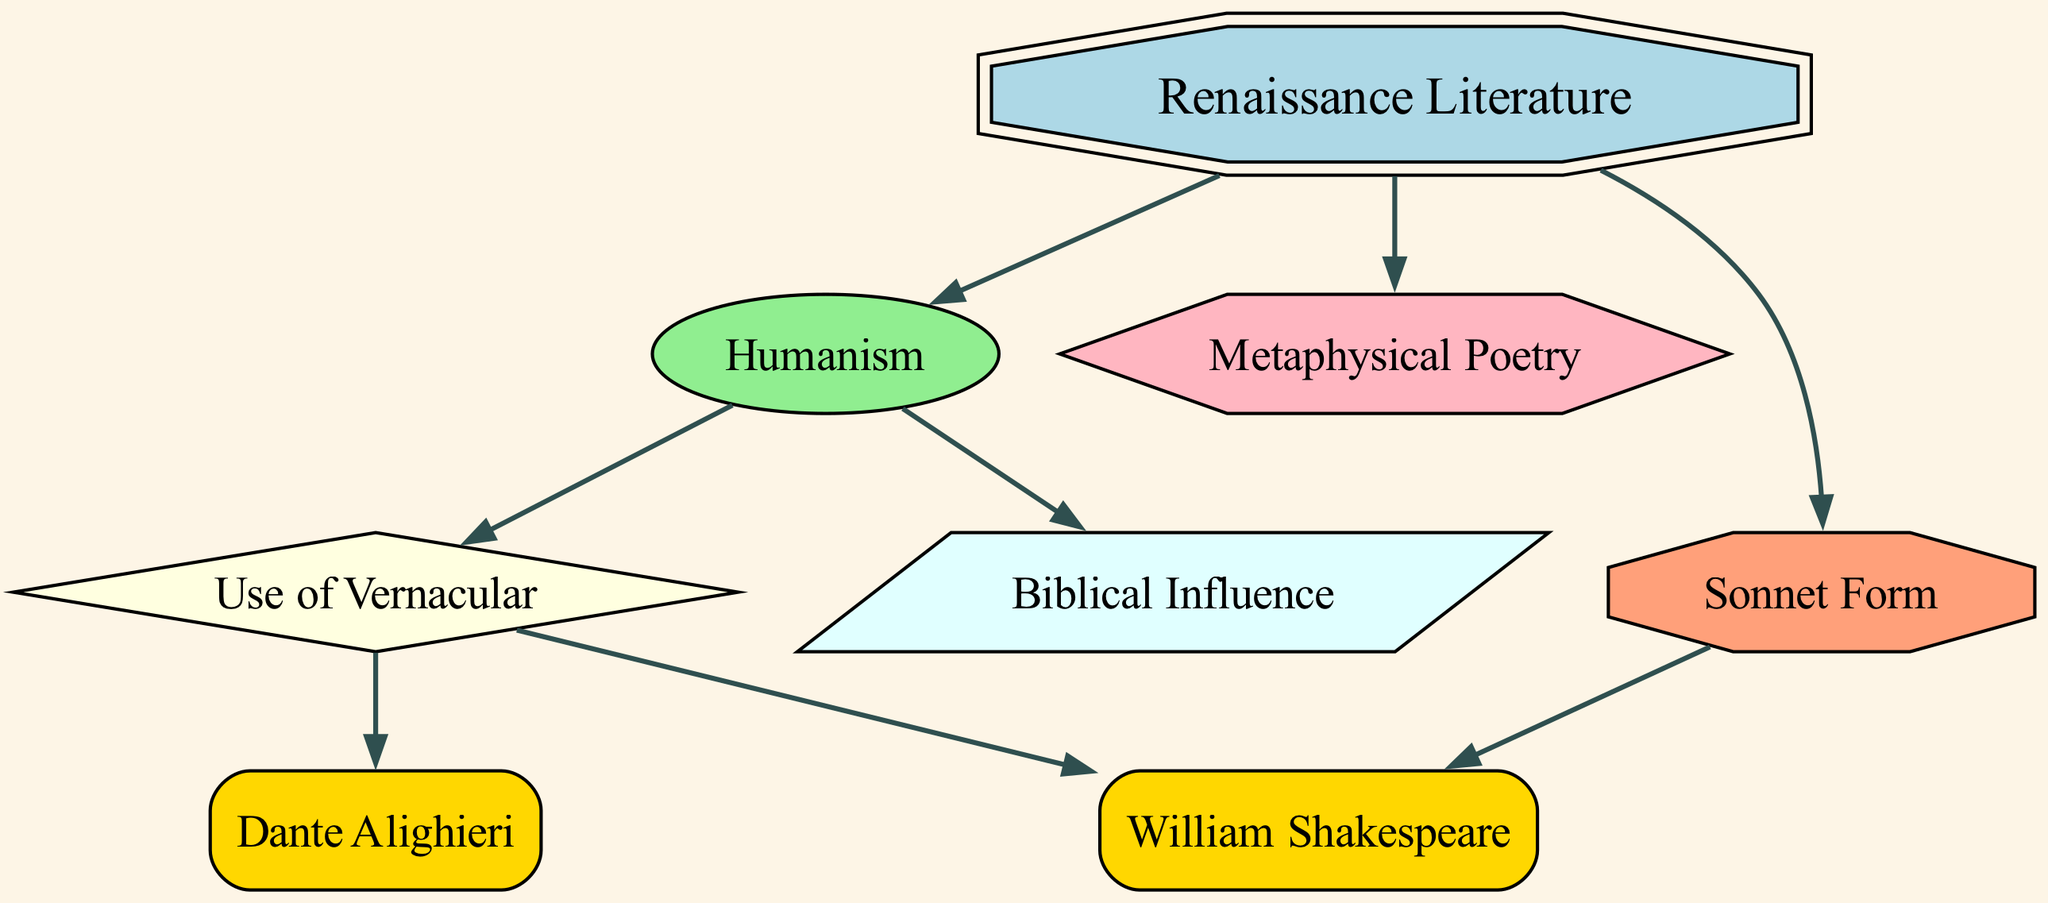What is the main subject of the diagram? The main subject, as indicated by the central or prominent node, is "Renaissance Literature." It serves as the focal point from which other concepts branch out.
Answer: Renaissance Literature How many nodes are there in the diagram? To determine the number of nodes, we count all the distinct entries in the 'nodes' list, which totals to 8.
Answer: 8 Which concept influences the use of vernacular? The diagram shows that "Humanism" directly influences "Use of Vernacular," indicating its pivotal role in promoting vernacular literature.
Answer: Humanism Who is connected through the use of vernacular? Both "William Shakespeare" and "Dante Alighieri" are connected through the "Use of Vernacular," as they derive from this concept.
Answer: William Shakespeare and Dante Alighieri What type of poetry is directly mentioned in the diagram? The diagram includes "Metaphysical Poetry," which is indicated as a separate node, showing its specific role in Renaissance literature.
Answer: Metaphysical Poetry How many connections does "William Shakespeare" have? "William Shakespeare" has two connections in the diagram: one from "Use of Vernacular" and another from "Sonnet Form." Therefore, the total is 2.
Answer: 2 Which concept is considered a direct result of Renaissance Literature? Two concepts, "Metaphysical Poetry" and "Sonnet Form," are both direct results of "Renaissance Literature," indicating its diverse impacts.
Answer: Metaphysical Poetry and Sonnet Form What shape is used for "Humanism"? The diagram specifies that "Humanism" is presented in an ellipse shape, as described in the node properties.
Answer: Ellipse What is the relationship between "Renaissance Literature" and "Biblical Influence"? The diagram shows a direct influence relationship from "Humanism" to "Biblical Influence," implying that Humanism connects Renaissance Literature to Biblical themes.
Answer: Influence 